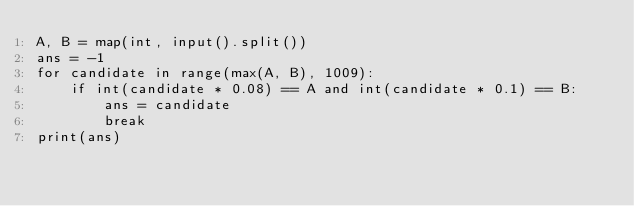<code> <loc_0><loc_0><loc_500><loc_500><_Python_>A, B = map(int, input().split())
ans = -1
for candidate in range(max(A, B), 1009):
    if int(candidate * 0.08) == A and int(candidate * 0.1) == B:
        ans = candidate
        break
print(ans)
</code> 